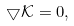Convert formula to latex. <formula><loc_0><loc_0><loc_500><loc_500>\bigtriangledown \mathcal { K } = 0 ,</formula> 